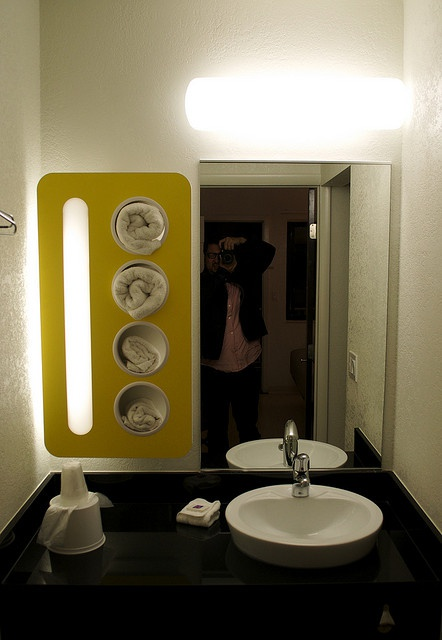Describe the objects in this image and their specific colors. I can see people in gray, black, and maroon tones, sink in gray, black, and tan tones, and cup in gray, olive, and tan tones in this image. 